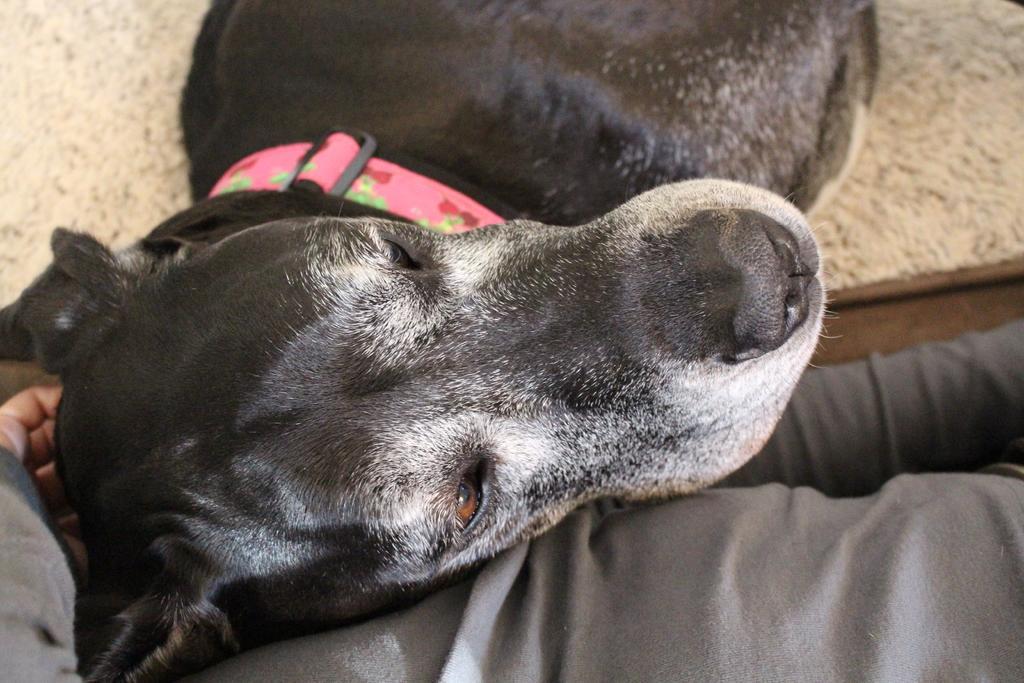Can you describe this image briefly? In this image we can see a dog keeping the head on the lap of a person. Dog is wearing a belt. 